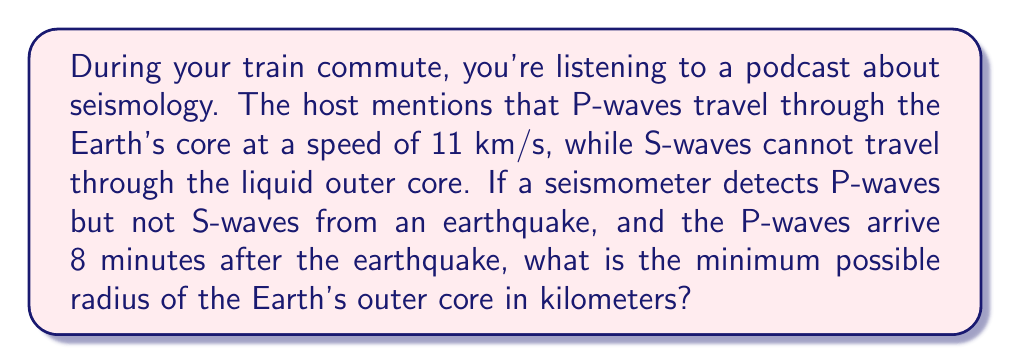Help me with this question. Let's approach this step-by-step:

1) First, we need to understand what the question is asking. We're looking for the minimum radius of the outer core, which means we're assuming the P-waves just grazed the outer core.

2) We know that:
   - P-waves travel at 11 km/s through the core
   - P-waves arrived 8 minutes after the earthquake

3) Convert 8 minutes to seconds:
   $8 \text{ minutes} \times 60 \text{ seconds/minute} = 480 \text{ seconds}$

4) Calculate the total distance traveled by the P-waves:
   $\text{Distance} = \text{Speed} \times \text{Time}$
   $\text{Distance} = 11 \text{ km/s} \times 480 \text{ s} = 5280 \text{ km}$

5) This distance represents the diameter of the path through the Earth, which is twice the radius of the outer core.

6) To get the radius, we divide by 2:
   $\text{Radius} = 5280 \text{ km} \div 2 = 2640 \text{ km}$

Therefore, the minimum possible radius of the Earth's outer core is 2640 km.
Answer: 2640 km 